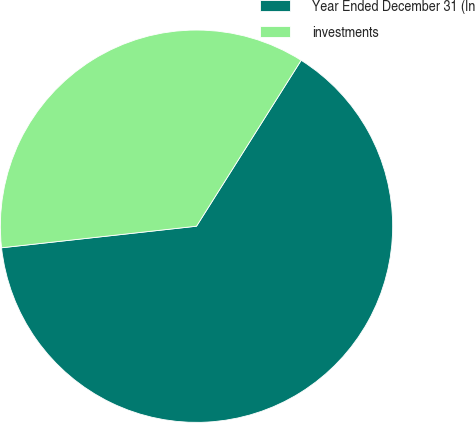Convert chart. <chart><loc_0><loc_0><loc_500><loc_500><pie_chart><fcel>Year Ended December 31 (In<fcel>investments<nl><fcel>64.29%<fcel>35.71%<nl></chart> 